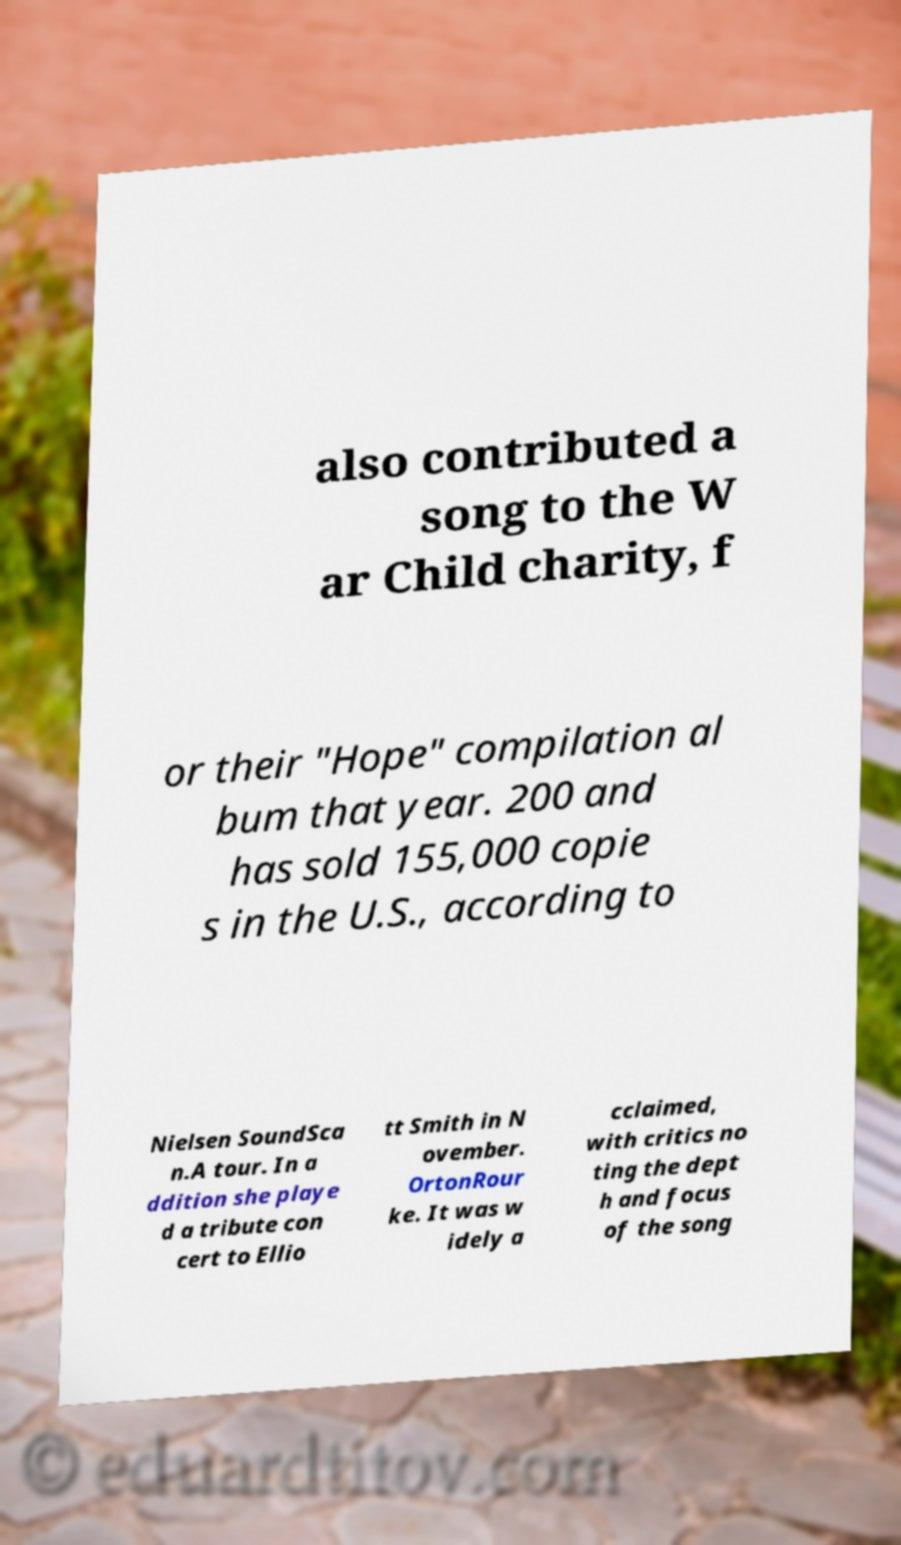For documentation purposes, I need the text within this image transcribed. Could you provide that? also contributed a song to the W ar Child charity, f or their "Hope" compilation al bum that year. 200 and has sold 155,000 copie s in the U.S., according to Nielsen SoundSca n.A tour. In a ddition she playe d a tribute con cert to Ellio tt Smith in N ovember. OrtonRour ke. It was w idely a cclaimed, with critics no ting the dept h and focus of the song 